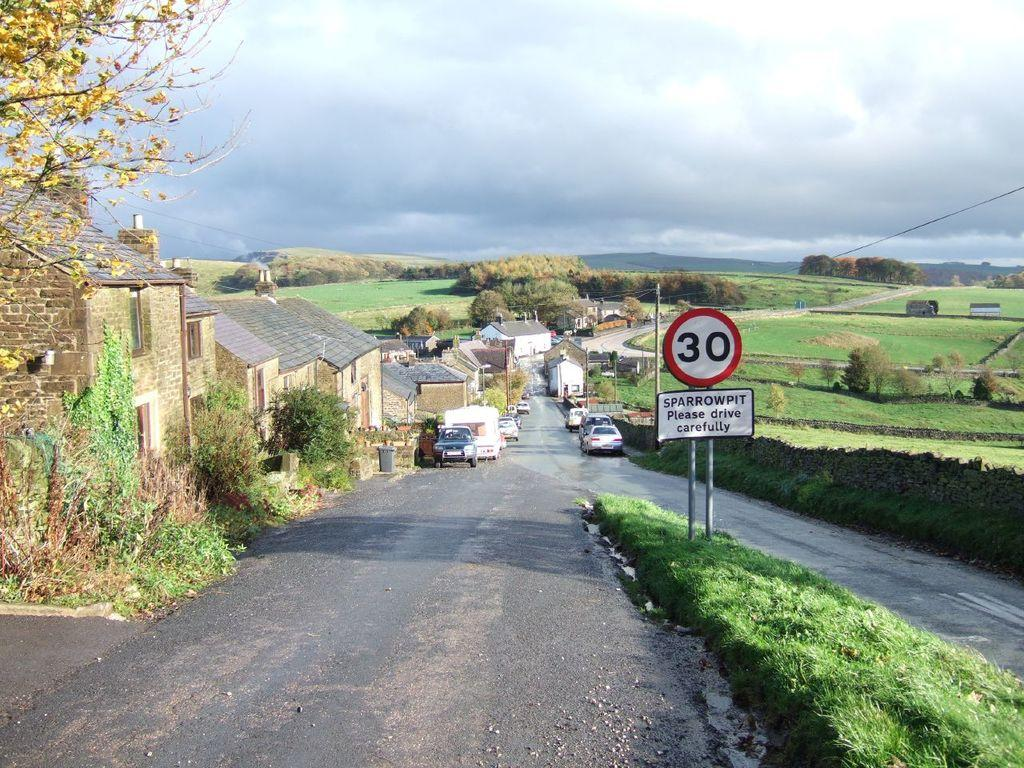<image>
Share a concise interpretation of the image provided. A merging country road labeled Sparrowpit asks that drivers are careful. 